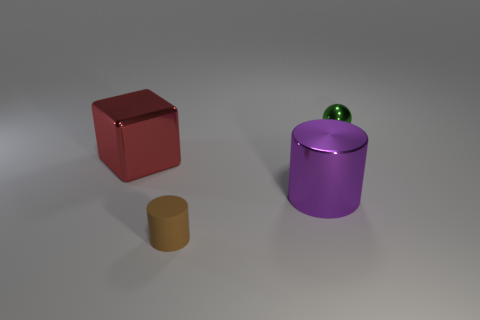Add 2 tiny brown matte blocks. How many objects exist? 6 Subtract all purple cylinders. How many cylinders are left? 1 Subtract all blue cubes. How many gray balls are left? 0 Subtract all big metal cubes. Subtract all big purple metallic things. How many objects are left? 2 Add 2 red shiny things. How many red shiny things are left? 3 Add 3 small cyan spheres. How many small cyan spheres exist? 3 Subtract 1 red cubes. How many objects are left? 3 Subtract all spheres. How many objects are left? 3 Subtract 1 cylinders. How many cylinders are left? 1 Subtract all yellow spheres. Subtract all gray cubes. How many spheres are left? 1 